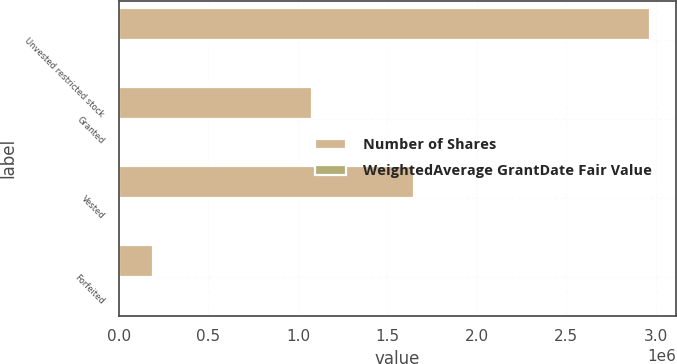<chart> <loc_0><loc_0><loc_500><loc_500><stacked_bar_chart><ecel><fcel>Unvested restricted stock<fcel>Granted<fcel>Vested<fcel>Forfeited<nl><fcel>Number of Shares<fcel>2.96471e+06<fcel>1.07895e+06<fcel>1.64829e+06<fcel>188499<nl><fcel>WeightedAverage GrantDate Fair Value<fcel>19.62<fcel>25.64<fcel>17.1<fcel>20.19<nl></chart> 